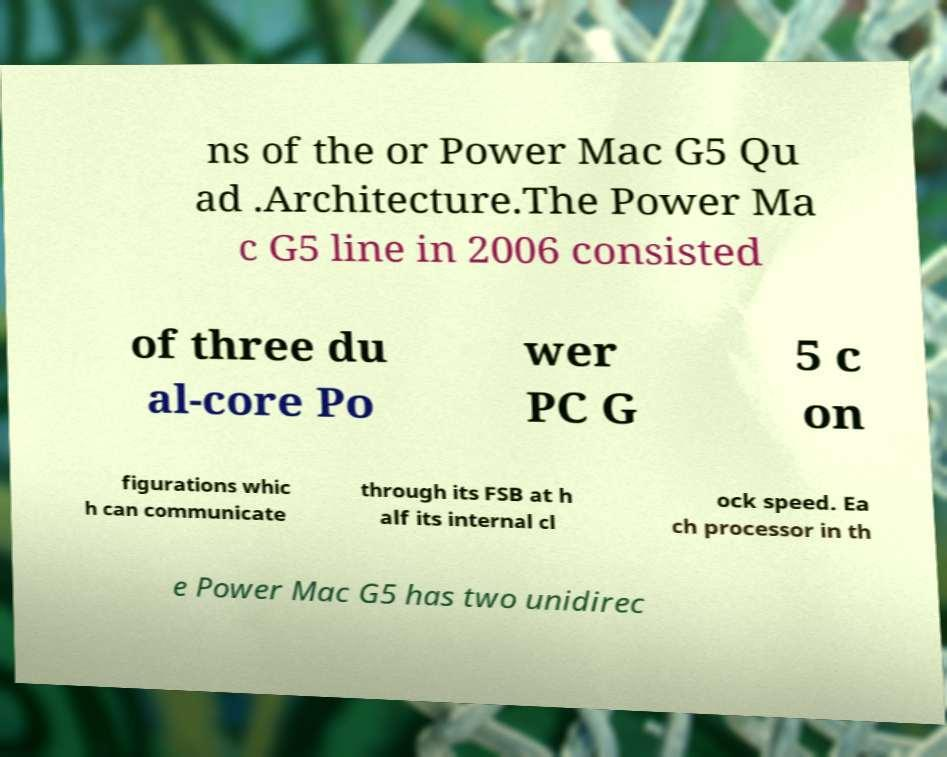There's text embedded in this image that I need extracted. Can you transcribe it verbatim? ns of the or Power Mac G5 Qu ad .Architecture.The Power Ma c G5 line in 2006 consisted of three du al-core Po wer PC G 5 c on figurations whic h can communicate through its FSB at h alf its internal cl ock speed. Ea ch processor in th e Power Mac G5 has two unidirec 